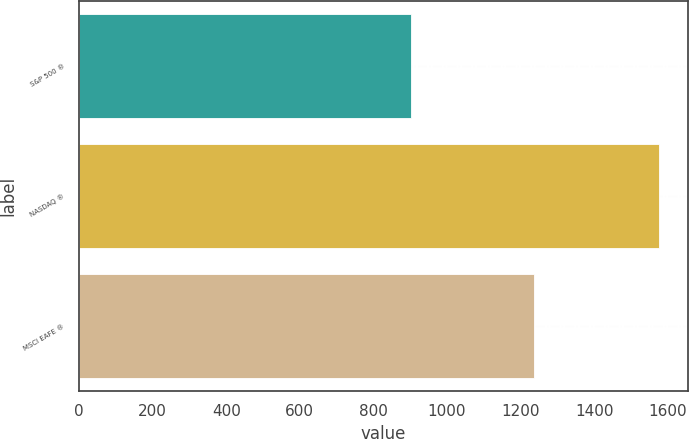<chart> <loc_0><loc_0><loc_500><loc_500><bar_chart><fcel>S&P 500 ®<fcel>NASDAQ ®<fcel>MSCI EAFE ®<nl><fcel>903<fcel>1577<fcel>1237<nl></chart> 